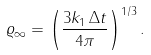<formula> <loc_0><loc_0><loc_500><loc_500>\varrho _ { \infty } = \left ( \frac { 3 k _ { 1 } \, \Delta t } { 4 \pi } \right ) ^ { 1 / 3 } .</formula> 